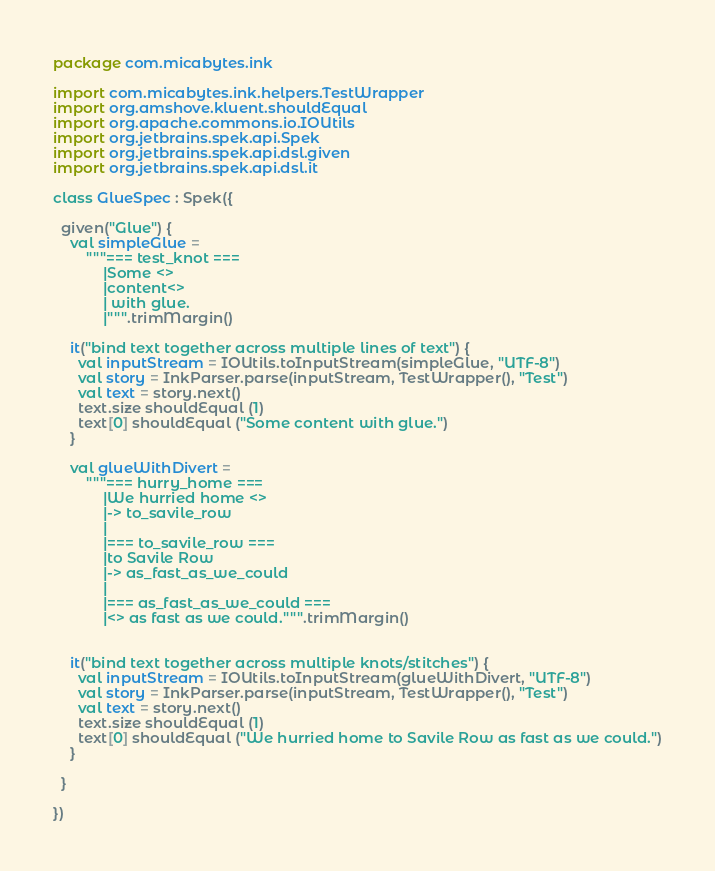<code> <loc_0><loc_0><loc_500><loc_500><_Kotlin_>package com.micabytes.ink

import com.micabytes.ink.helpers.TestWrapper
import org.amshove.kluent.shouldEqual
import org.apache.commons.io.IOUtils
import org.jetbrains.spek.api.Spek
import org.jetbrains.spek.api.dsl.given
import org.jetbrains.spek.api.dsl.it

class GlueSpec : Spek({

  given("Glue") {
    val simpleGlue =
        """=== test_knot ===
            |Some <>
            |content<>
            | with glue.
            |""".trimMargin()

    it("bind text together across multiple lines of text") {
      val inputStream = IOUtils.toInputStream(simpleGlue, "UTF-8")
      val story = InkParser.parse(inputStream, TestWrapper(), "Test")
      val text = story.next()
      text.size shouldEqual (1)
      text[0] shouldEqual ("Some content with glue.")
    }

    val glueWithDivert =
        """=== hurry_home ===
            |We hurried home <>
            |-> to_savile_row
            |
            |=== to_savile_row ===
            |to Savile Row
            |-> as_fast_as_we_could
            |
            |=== as_fast_as_we_could ===
            |<> as fast as we could.""".trimMargin()


    it("bind text together across multiple knots/stitches") {
      val inputStream = IOUtils.toInputStream(glueWithDivert, "UTF-8")
      val story = InkParser.parse(inputStream, TestWrapper(), "Test")
      val text = story.next()
      text.size shouldEqual (1)
      text[0] shouldEqual ("We hurried home to Savile Row as fast as we could.")
    }

  }

})
</code> 